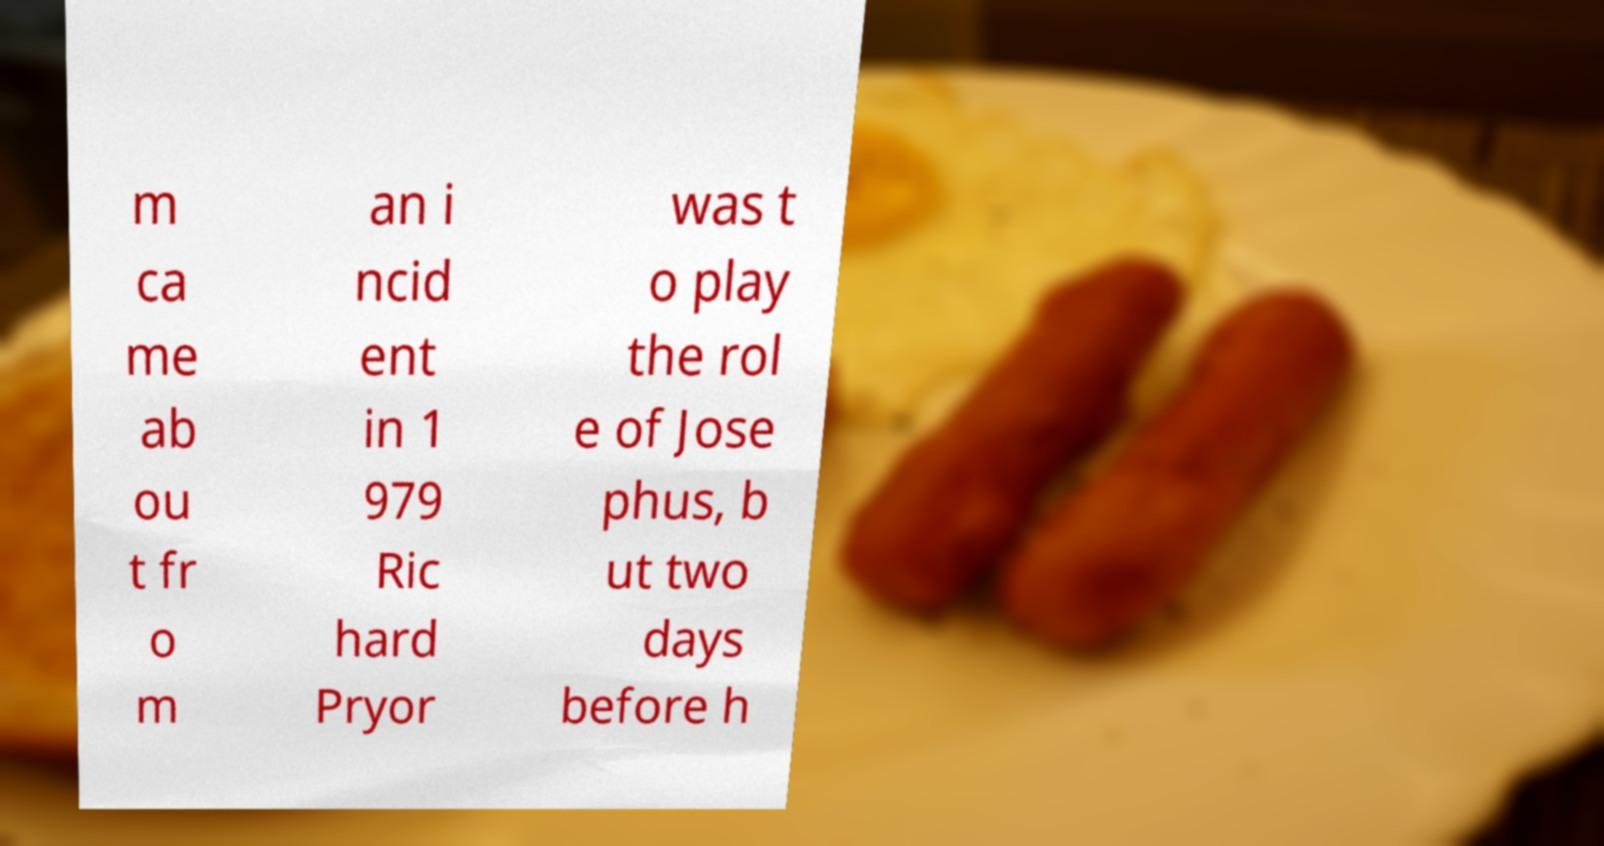Can you accurately transcribe the text from the provided image for me? m ca me ab ou t fr o m an i ncid ent in 1 979 Ric hard Pryor was t o play the rol e of Jose phus, b ut two days before h 